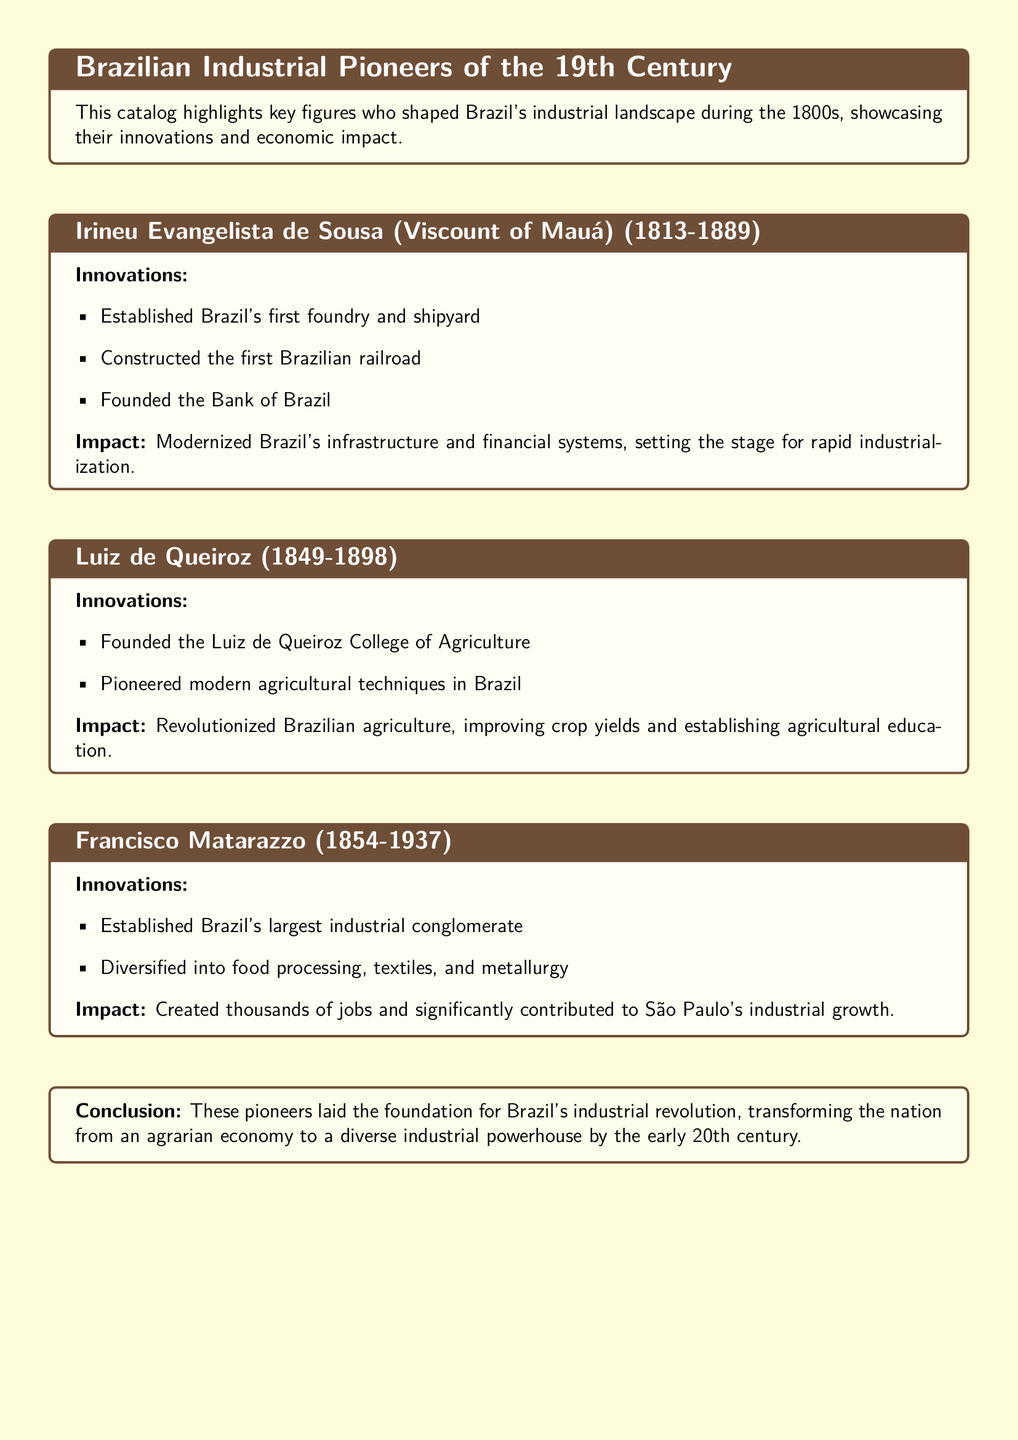What is the name of the first Brazilian railroad constructor? The document states that Irineu Evangelista de Sousa constructed the first Brazilian railroad.
Answer: Irineu Evangelista de Sousa What years did Francisco Matarazzo live? The document provides the years of Francisco Matarazzo's life as 1854 to 1937.
Answer: 1854-1937 What was a key innovation of Luiz de Queiroz? According to the document, he founded the Luiz de Queiroz College of Agriculture as a key innovation.
Answer: Luiz de Queiroz College of Agriculture How many major industries did Francisco Matarazzo diversify into? The document mentions that he diversified into food processing, textiles, and metallurgy, which accounts for three major industries.
Answer: Three What impact did Irineu Evangelista de Sousa have on Brazil? The document states that he modernized Brazil's infrastructure and financial systems, indicating a significant impact.
Answer: Modernized infrastructure and financial systems What was the main focus of Luiz de Queiroz's innovations? The document explains that Luiz de Queiroz pioneered modern agricultural techniques, indicating his focus on agriculture.
Answer: Agriculture What was the main contribution of Francisco Matarazzo to São Paulo? The document indicates that he created thousands of jobs, highlighting his main contribution.
Answer: Created thousands of jobs What did the pioneers contribute to Brazil's economy by the early 20th century? The conclusion in the document emphasizes that these pioneers transformed Brazil's economy into a diverse industrial powerhouse.
Answer: Diverse industrial powerhouse 